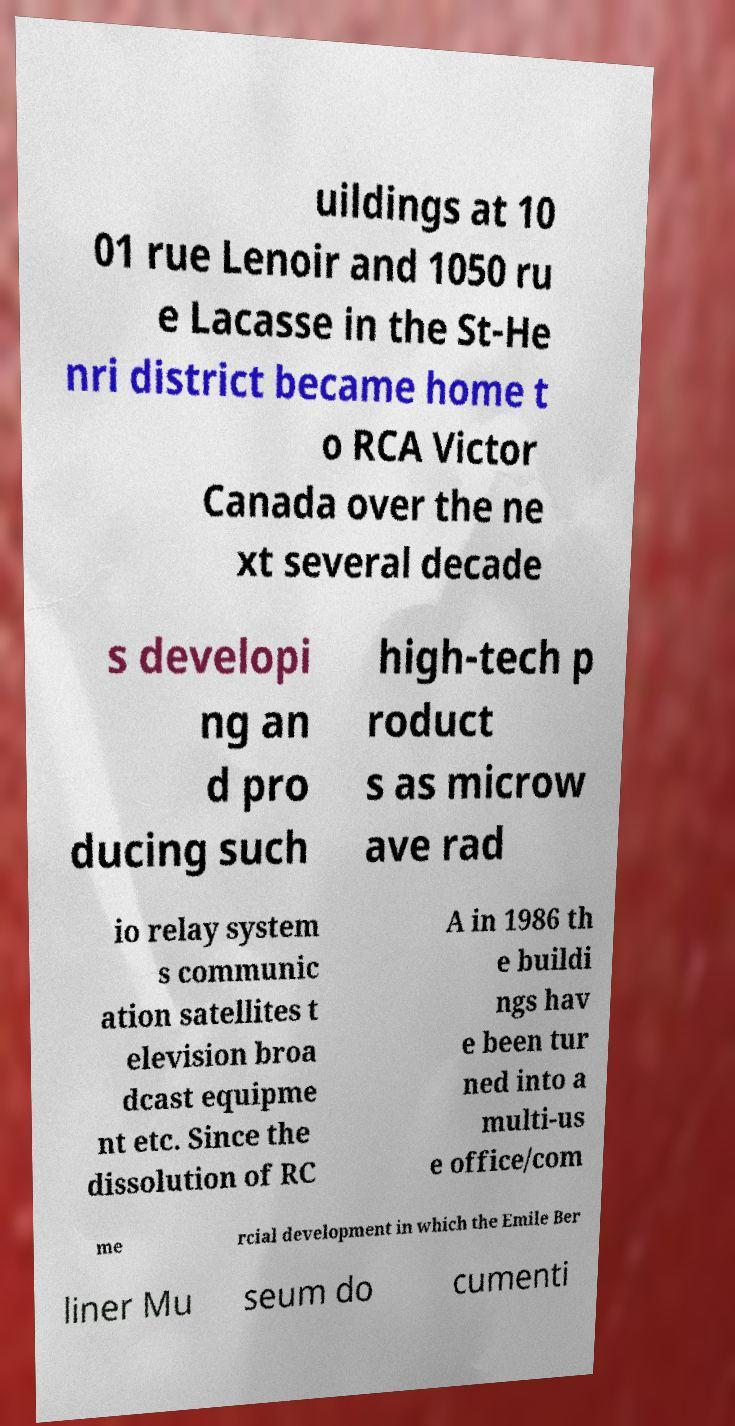Can you read and provide the text displayed in the image?This photo seems to have some interesting text. Can you extract and type it out for me? uildings at 10 01 rue Lenoir and 1050 ru e Lacasse in the St-He nri district became home t o RCA Victor Canada over the ne xt several decade s developi ng an d pro ducing such high-tech p roduct s as microw ave rad io relay system s communic ation satellites t elevision broa dcast equipme nt etc. Since the dissolution of RC A in 1986 th e buildi ngs hav e been tur ned into a multi-us e office/com me rcial development in which the Emile Ber liner Mu seum do cumenti 